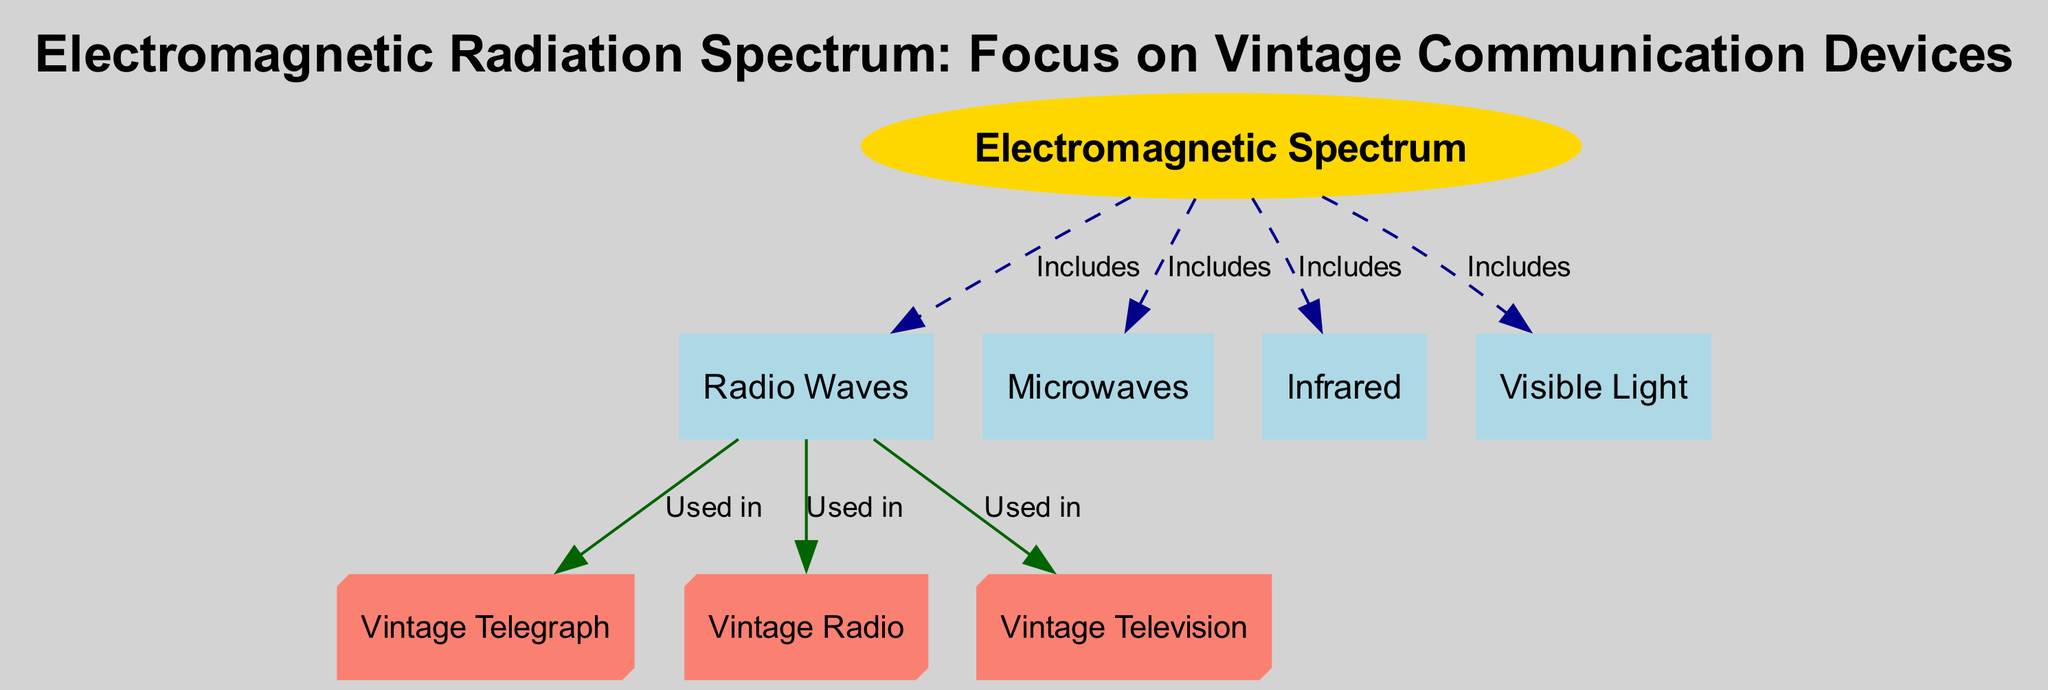What is the title of the diagram? The title is explicitly stated at the top of the diagram, which is "Electromagnetic Radiation Spectrum: Focus on Vintage Communication Devices."
Answer: Electromagnetic Radiation Spectrum: Focus on Vintage Communication Devices How many nodes are in the diagram? To find the number of nodes, we count each node present in the diagram. There are eight nodes listed, which include the Electromagnetic Spectrum, Radio Waves, Microwaves, Infrared, Visible Light, Vintage Telegraph, Vintage Radio, and Vintage Television.
Answer: 8 Which device uses radio waves? By examining the edges connected to the "radio_waves" node, we identify that three devices are directly linked to it: Vintage Telegraph, Vintage Radio, and Vintage Television. Therefore, any of these devices is a correct answer.
Answer: Vintage Telegraph What type of wave includes visible light? The "visible_light" node is connected to "spectrum" through an edge labeled "Includes," indicating that visible light is a type of wave that is part of or exists within the electromagnetic spectrum.
Answer: Electromagnetic Spectrum How many devices use radio waves? By analyzing the edges stemming from the "radio_waves" node, we see that there are three devices that explicitly use radio waves: the Vintage Telegraph, Vintage Radio, and Vintage Television. Thus, the total count of devices is three.
Answer: 3 What is the relationship between microwaves and the electromagnetic spectrum? The "microwaves" node connects to the "spectrum" node, where the edge is labeled "Includes," indicating that microwaves are a component of the electromagnetic spectrum.
Answer: Includes Which category does the vintage radio fall under? The "vintage_radio" node is connected to the "radio_waves" node with the edge labeled "Used in," which denotes that vintage radio operates within the realm of radio waves, categorizing it as a vintage communication device relying on this wave type.
Answer: Vintage Communication Device How are infrared and visible light related to the electromagnetic spectrum? Both "infrared" and "visible light" nodes are separately connected to the "spectrum" node with edges labeled "Includes," which indicates that both of these are types of electromagnetic waves contained within the broader electromagnetic spectrum.
Answer: Includes 